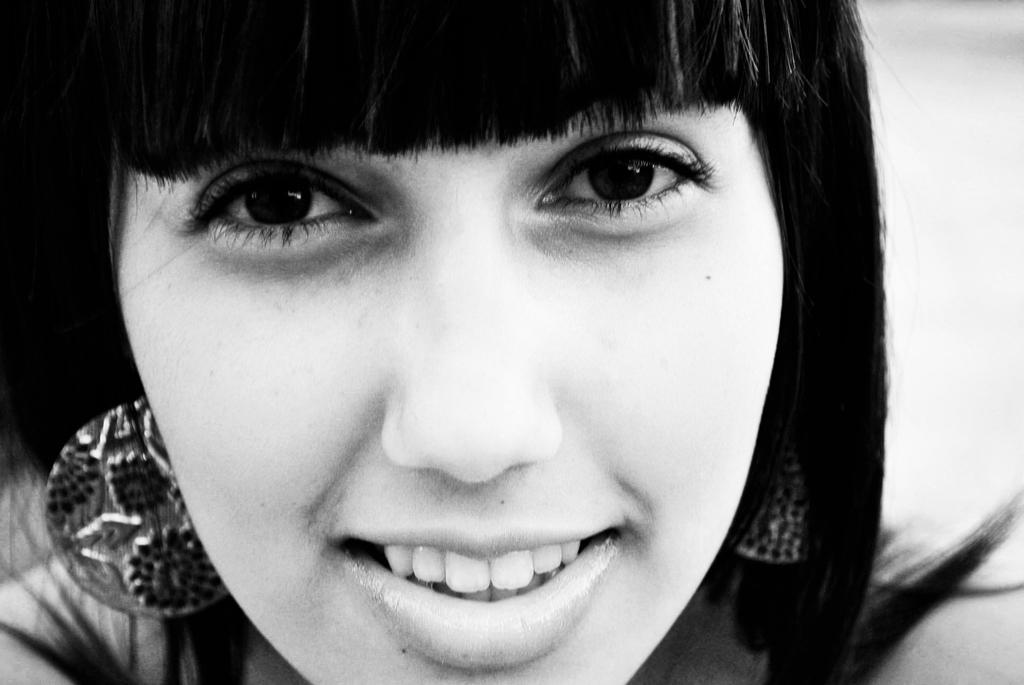What is the color scheme of the image? The image is black and white. What can be seen in the image? There are women in the image. What type of writing instrument is being used by the women in the image? There is no writing instrument visible in the image, as it is black and white and only features women. What type of calculator can be seen on the table in the image? There is no calculator present in the image; it only features women. 